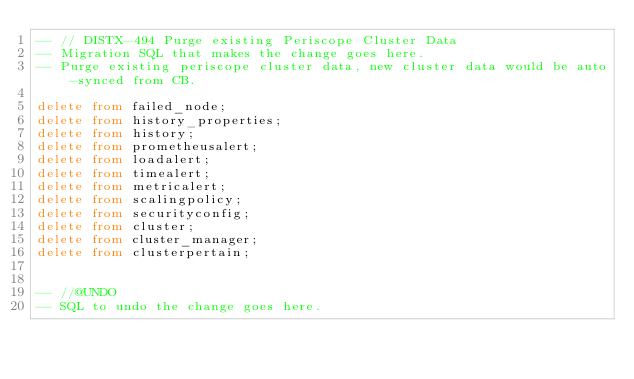<code> <loc_0><loc_0><loc_500><loc_500><_SQL_>-- // DISTX-494 Purge existing Periscope Cluster Data
-- Migration SQL that makes the change goes here.
-- Purge existing periscope cluster data, new cluster data would be auto-synced from CB.

delete from failed_node;
delete from history_properties;
delete from history;
delete from prometheusalert;
delete from loadalert;
delete from timealert;
delete from metricalert;
delete from scalingpolicy;
delete from securityconfig;
delete from cluster;
delete from cluster_manager;
delete from clusterpertain;


-- //@UNDO
-- SQL to undo the change goes here.


</code> 